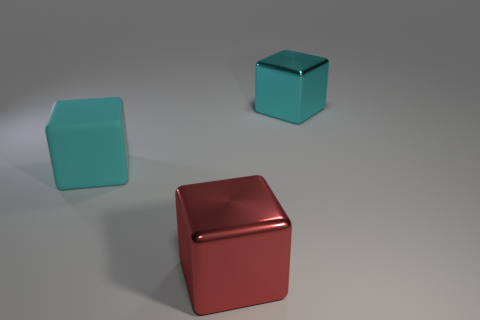Add 2 tiny yellow rubber balls. How many objects exist? 5 Subtract all purple balls. Subtract all big red shiny things. How many objects are left? 2 Add 1 big red metal cubes. How many big red metal cubes are left? 2 Add 1 red metallic blocks. How many red metallic blocks exist? 2 Subtract 0 green cubes. How many objects are left? 3 